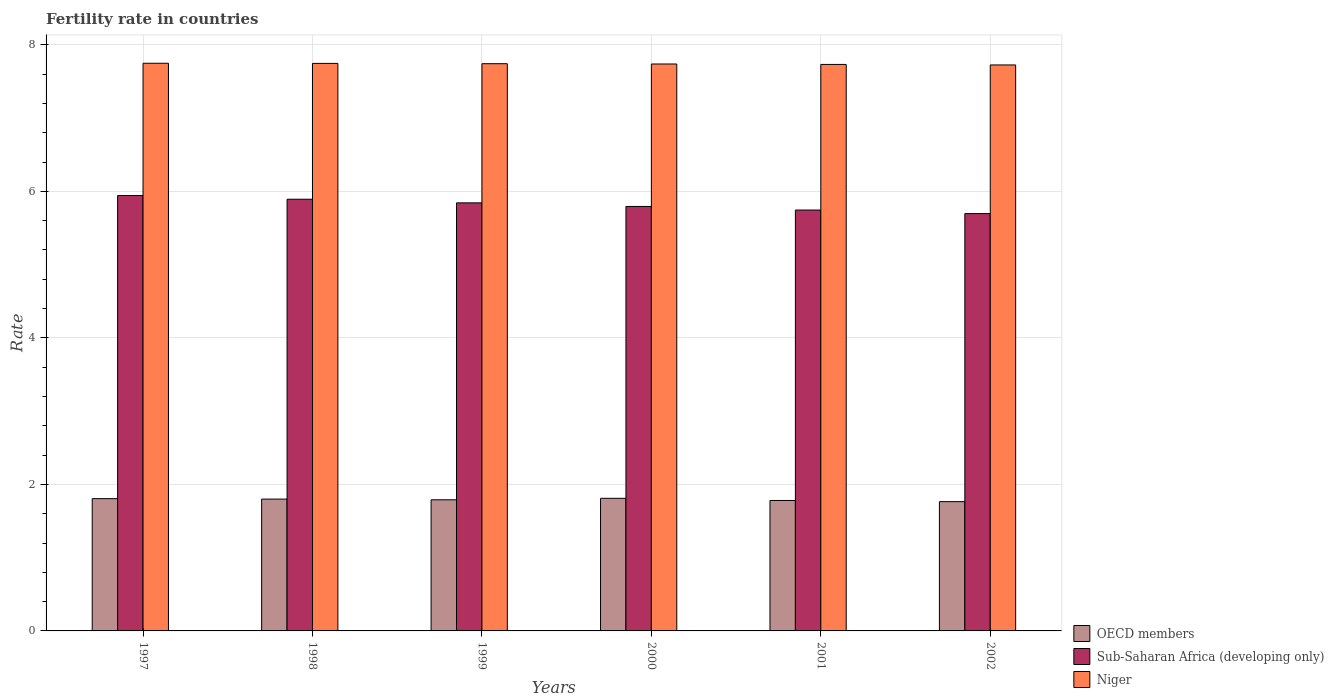How many different coloured bars are there?
Ensure brevity in your answer.  3. How many bars are there on the 3rd tick from the right?
Make the answer very short. 3. What is the label of the 6th group of bars from the left?
Your answer should be compact. 2002. What is the fertility rate in Sub-Saharan Africa (developing only) in 1997?
Make the answer very short. 5.94. Across all years, what is the maximum fertility rate in Sub-Saharan Africa (developing only)?
Offer a terse response. 5.94. Across all years, what is the minimum fertility rate in Sub-Saharan Africa (developing only)?
Offer a very short reply. 5.7. What is the total fertility rate in Niger in the graph?
Your answer should be very brief. 46.43. What is the difference between the fertility rate in Sub-Saharan Africa (developing only) in 1998 and that in 2002?
Give a very brief answer. 0.2. What is the difference between the fertility rate in OECD members in 2000 and the fertility rate in Sub-Saharan Africa (developing only) in 1998?
Your answer should be compact. -4.08. What is the average fertility rate in Niger per year?
Your answer should be very brief. 7.74. In the year 2002, what is the difference between the fertility rate in OECD members and fertility rate in Sub-Saharan Africa (developing only)?
Your answer should be compact. -3.93. What is the ratio of the fertility rate in Sub-Saharan Africa (developing only) in 1998 to that in 2002?
Your answer should be very brief. 1.03. What is the difference between the highest and the second highest fertility rate in Niger?
Provide a short and direct response. 0. What is the difference between the highest and the lowest fertility rate in OECD members?
Make the answer very short. 0.05. In how many years, is the fertility rate in Niger greater than the average fertility rate in Niger taken over all years?
Give a very brief answer. 3. Is the sum of the fertility rate in Niger in 1998 and 1999 greater than the maximum fertility rate in OECD members across all years?
Offer a very short reply. Yes. What does the 2nd bar from the left in 1998 represents?
Keep it short and to the point. Sub-Saharan Africa (developing only). What does the 3rd bar from the right in 2001 represents?
Provide a short and direct response. OECD members. Is it the case that in every year, the sum of the fertility rate in OECD members and fertility rate in Niger is greater than the fertility rate in Sub-Saharan Africa (developing only)?
Provide a succinct answer. Yes. Are all the bars in the graph horizontal?
Provide a short and direct response. No. Where does the legend appear in the graph?
Make the answer very short. Bottom right. How many legend labels are there?
Give a very brief answer. 3. What is the title of the graph?
Your answer should be compact. Fertility rate in countries. Does "South Sudan" appear as one of the legend labels in the graph?
Offer a very short reply. No. What is the label or title of the Y-axis?
Your answer should be compact. Rate. What is the Rate of OECD members in 1997?
Provide a short and direct response. 1.81. What is the Rate of Sub-Saharan Africa (developing only) in 1997?
Your answer should be very brief. 5.94. What is the Rate of Niger in 1997?
Ensure brevity in your answer.  7.75. What is the Rate of OECD members in 1998?
Your answer should be very brief. 1.8. What is the Rate of Sub-Saharan Africa (developing only) in 1998?
Provide a short and direct response. 5.89. What is the Rate in Niger in 1998?
Keep it short and to the point. 7.75. What is the Rate in OECD members in 1999?
Keep it short and to the point. 1.79. What is the Rate in Sub-Saharan Africa (developing only) in 1999?
Your response must be concise. 5.84. What is the Rate in Niger in 1999?
Your response must be concise. 7.74. What is the Rate in OECD members in 2000?
Your response must be concise. 1.81. What is the Rate in Sub-Saharan Africa (developing only) in 2000?
Ensure brevity in your answer.  5.79. What is the Rate in Niger in 2000?
Keep it short and to the point. 7.74. What is the Rate of OECD members in 2001?
Offer a terse response. 1.78. What is the Rate in Sub-Saharan Africa (developing only) in 2001?
Provide a succinct answer. 5.74. What is the Rate of Niger in 2001?
Ensure brevity in your answer.  7.73. What is the Rate in OECD members in 2002?
Make the answer very short. 1.76. What is the Rate of Sub-Saharan Africa (developing only) in 2002?
Your response must be concise. 5.7. What is the Rate of Niger in 2002?
Provide a succinct answer. 7.72. Across all years, what is the maximum Rate in OECD members?
Ensure brevity in your answer.  1.81. Across all years, what is the maximum Rate of Sub-Saharan Africa (developing only)?
Offer a terse response. 5.94. Across all years, what is the maximum Rate in Niger?
Give a very brief answer. 7.75. Across all years, what is the minimum Rate of OECD members?
Your response must be concise. 1.76. Across all years, what is the minimum Rate in Sub-Saharan Africa (developing only)?
Provide a succinct answer. 5.7. Across all years, what is the minimum Rate in Niger?
Provide a short and direct response. 7.72. What is the total Rate in OECD members in the graph?
Make the answer very short. 10.75. What is the total Rate of Sub-Saharan Africa (developing only) in the graph?
Make the answer very short. 34.91. What is the total Rate of Niger in the graph?
Make the answer very short. 46.43. What is the difference between the Rate of OECD members in 1997 and that in 1998?
Ensure brevity in your answer.  0.01. What is the difference between the Rate in Sub-Saharan Africa (developing only) in 1997 and that in 1998?
Offer a terse response. 0.05. What is the difference between the Rate in Niger in 1997 and that in 1998?
Your response must be concise. 0. What is the difference between the Rate in OECD members in 1997 and that in 1999?
Your response must be concise. 0.02. What is the difference between the Rate of Sub-Saharan Africa (developing only) in 1997 and that in 1999?
Ensure brevity in your answer.  0.1. What is the difference between the Rate of Niger in 1997 and that in 1999?
Provide a short and direct response. 0.01. What is the difference between the Rate of OECD members in 1997 and that in 2000?
Your answer should be very brief. -0. What is the difference between the Rate of Sub-Saharan Africa (developing only) in 1997 and that in 2000?
Give a very brief answer. 0.15. What is the difference between the Rate in Niger in 1997 and that in 2000?
Offer a very short reply. 0.01. What is the difference between the Rate in OECD members in 1997 and that in 2001?
Your response must be concise. 0.02. What is the difference between the Rate of Sub-Saharan Africa (developing only) in 1997 and that in 2001?
Ensure brevity in your answer.  0.2. What is the difference between the Rate of Niger in 1997 and that in 2001?
Offer a very short reply. 0.02. What is the difference between the Rate of OECD members in 1997 and that in 2002?
Your answer should be very brief. 0.04. What is the difference between the Rate in Sub-Saharan Africa (developing only) in 1997 and that in 2002?
Your answer should be compact. 0.25. What is the difference between the Rate in Niger in 1997 and that in 2002?
Keep it short and to the point. 0.02. What is the difference between the Rate in OECD members in 1998 and that in 1999?
Offer a very short reply. 0.01. What is the difference between the Rate in Sub-Saharan Africa (developing only) in 1998 and that in 1999?
Offer a terse response. 0.05. What is the difference between the Rate of Niger in 1998 and that in 1999?
Make the answer very short. 0. What is the difference between the Rate in OECD members in 1998 and that in 2000?
Give a very brief answer. -0.01. What is the difference between the Rate of Sub-Saharan Africa (developing only) in 1998 and that in 2000?
Provide a succinct answer. 0.1. What is the difference between the Rate of Niger in 1998 and that in 2000?
Your response must be concise. 0.01. What is the difference between the Rate in OECD members in 1998 and that in 2001?
Your answer should be very brief. 0.02. What is the difference between the Rate in Sub-Saharan Africa (developing only) in 1998 and that in 2001?
Your answer should be very brief. 0.15. What is the difference between the Rate in Niger in 1998 and that in 2001?
Your answer should be compact. 0.01. What is the difference between the Rate of OECD members in 1998 and that in 2002?
Ensure brevity in your answer.  0.03. What is the difference between the Rate of Sub-Saharan Africa (developing only) in 1998 and that in 2002?
Provide a short and direct response. 0.2. What is the difference between the Rate in Niger in 1998 and that in 2002?
Your response must be concise. 0.02. What is the difference between the Rate in OECD members in 1999 and that in 2000?
Make the answer very short. -0.02. What is the difference between the Rate in Sub-Saharan Africa (developing only) in 1999 and that in 2000?
Your response must be concise. 0.05. What is the difference between the Rate in Niger in 1999 and that in 2000?
Give a very brief answer. 0. What is the difference between the Rate of OECD members in 1999 and that in 2001?
Keep it short and to the point. 0.01. What is the difference between the Rate in Sub-Saharan Africa (developing only) in 1999 and that in 2001?
Keep it short and to the point. 0.1. What is the difference between the Rate of Niger in 1999 and that in 2001?
Keep it short and to the point. 0.01. What is the difference between the Rate of OECD members in 1999 and that in 2002?
Keep it short and to the point. 0.03. What is the difference between the Rate of Sub-Saharan Africa (developing only) in 1999 and that in 2002?
Your answer should be compact. 0.15. What is the difference between the Rate in Niger in 1999 and that in 2002?
Offer a very short reply. 0.02. What is the difference between the Rate in OECD members in 2000 and that in 2001?
Make the answer very short. 0.03. What is the difference between the Rate of Sub-Saharan Africa (developing only) in 2000 and that in 2001?
Your answer should be very brief. 0.05. What is the difference between the Rate in Niger in 2000 and that in 2001?
Keep it short and to the point. 0.01. What is the difference between the Rate of OECD members in 2000 and that in 2002?
Your answer should be compact. 0.05. What is the difference between the Rate of Sub-Saharan Africa (developing only) in 2000 and that in 2002?
Your answer should be compact. 0.1. What is the difference between the Rate of Niger in 2000 and that in 2002?
Keep it short and to the point. 0.01. What is the difference between the Rate in OECD members in 2001 and that in 2002?
Ensure brevity in your answer.  0.02. What is the difference between the Rate of Sub-Saharan Africa (developing only) in 2001 and that in 2002?
Give a very brief answer. 0.05. What is the difference between the Rate in Niger in 2001 and that in 2002?
Ensure brevity in your answer.  0.01. What is the difference between the Rate in OECD members in 1997 and the Rate in Sub-Saharan Africa (developing only) in 1998?
Offer a terse response. -4.09. What is the difference between the Rate of OECD members in 1997 and the Rate of Niger in 1998?
Your response must be concise. -5.94. What is the difference between the Rate of Sub-Saharan Africa (developing only) in 1997 and the Rate of Niger in 1998?
Provide a short and direct response. -1.8. What is the difference between the Rate in OECD members in 1997 and the Rate in Sub-Saharan Africa (developing only) in 1999?
Your answer should be compact. -4.04. What is the difference between the Rate of OECD members in 1997 and the Rate of Niger in 1999?
Your answer should be very brief. -5.94. What is the difference between the Rate of Sub-Saharan Africa (developing only) in 1997 and the Rate of Niger in 1999?
Your answer should be very brief. -1.8. What is the difference between the Rate in OECD members in 1997 and the Rate in Sub-Saharan Africa (developing only) in 2000?
Offer a very short reply. -3.99. What is the difference between the Rate in OECD members in 1997 and the Rate in Niger in 2000?
Provide a short and direct response. -5.93. What is the difference between the Rate in Sub-Saharan Africa (developing only) in 1997 and the Rate in Niger in 2000?
Provide a succinct answer. -1.8. What is the difference between the Rate of OECD members in 1997 and the Rate of Sub-Saharan Africa (developing only) in 2001?
Give a very brief answer. -3.94. What is the difference between the Rate of OECD members in 1997 and the Rate of Niger in 2001?
Make the answer very short. -5.93. What is the difference between the Rate in Sub-Saharan Africa (developing only) in 1997 and the Rate in Niger in 2001?
Make the answer very short. -1.79. What is the difference between the Rate in OECD members in 1997 and the Rate in Sub-Saharan Africa (developing only) in 2002?
Your answer should be very brief. -3.89. What is the difference between the Rate of OECD members in 1997 and the Rate of Niger in 2002?
Offer a very short reply. -5.92. What is the difference between the Rate of Sub-Saharan Africa (developing only) in 1997 and the Rate of Niger in 2002?
Provide a succinct answer. -1.78. What is the difference between the Rate in OECD members in 1998 and the Rate in Sub-Saharan Africa (developing only) in 1999?
Make the answer very short. -4.04. What is the difference between the Rate of OECD members in 1998 and the Rate of Niger in 1999?
Your response must be concise. -5.94. What is the difference between the Rate in Sub-Saharan Africa (developing only) in 1998 and the Rate in Niger in 1999?
Your answer should be very brief. -1.85. What is the difference between the Rate of OECD members in 1998 and the Rate of Sub-Saharan Africa (developing only) in 2000?
Offer a terse response. -3.99. What is the difference between the Rate in OECD members in 1998 and the Rate in Niger in 2000?
Your response must be concise. -5.94. What is the difference between the Rate of Sub-Saharan Africa (developing only) in 1998 and the Rate of Niger in 2000?
Give a very brief answer. -1.85. What is the difference between the Rate in OECD members in 1998 and the Rate in Sub-Saharan Africa (developing only) in 2001?
Your answer should be very brief. -3.95. What is the difference between the Rate of OECD members in 1998 and the Rate of Niger in 2001?
Offer a very short reply. -5.93. What is the difference between the Rate of Sub-Saharan Africa (developing only) in 1998 and the Rate of Niger in 2001?
Your answer should be very brief. -1.84. What is the difference between the Rate in OECD members in 1998 and the Rate in Sub-Saharan Africa (developing only) in 2002?
Keep it short and to the point. -3.9. What is the difference between the Rate in OECD members in 1998 and the Rate in Niger in 2002?
Offer a very short reply. -5.93. What is the difference between the Rate of Sub-Saharan Africa (developing only) in 1998 and the Rate of Niger in 2002?
Your answer should be compact. -1.83. What is the difference between the Rate in OECD members in 1999 and the Rate in Sub-Saharan Africa (developing only) in 2000?
Offer a very short reply. -4. What is the difference between the Rate in OECD members in 1999 and the Rate in Niger in 2000?
Give a very brief answer. -5.95. What is the difference between the Rate of Sub-Saharan Africa (developing only) in 1999 and the Rate of Niger in 2000?
Provide a succinct answer. -1.9. What is the difference between the Rate of OECD members in 1999 and the Rate of Sub-Saharan Africa (developing only) in 2001?
Give a very brief answer. -3.95. What is the difference between the Rate in OECD members in 1999 and the Rate in Niger in 2001?
Offer a terse response. -5.94. What is the difference between the Rate of Sub-Saharan Africa (developing only) in 1999 and the Rate of Niger in 2001?
Provide a succinct answer. -1.89. What is the difference between the Rate in OECD members in 1999 and the Rate in Sub-Saharan Africa (developing only) in 2002?
Offer a terse response. -3.91. What is the difference between the Rate of OECD members in 1999 and the Rate of Niger in 2002?
Your answer should be compact. -5.94. What is the difference between the Rate of Sub-Saharan Africa (developing only) in 1999 and the Rate of Niger in 2002?
Offer a terse response. -1.88. What is the difference between the Rate in OECD members in 2000 and the Rate in Sub-Saharan Africa (developing only) in 2001?
Provide a short and direct response. -3.93. What is the difference between the Rate of OECD members in 2000 and the Rate of Niger in 2001?
Make the answer very short. -5.92. What is the difference between the Rate of Sub-Saharan Africa (developing only) in 2000 and the Rate of Niger in 2001?
Keep it short and to the point. -1.94. What is the difference between the Rate in OECD members in 2000 and the Rate in Sub-Saharan Africa (developing only) in 2002?
Give a very brief answer. -3.89. What is the difference between the Rate of OECD members in 2000 and the Rate of Niger in 2002?
Offer a terse response. -5.92. What is the difference between the Rate of Sub-Saharan Africa (developing only) in 2000 and the Rate of Niger in 2002?
Make the answer very short. -1.93. What is the difference between the Rate of OECD members in 2001 and the Rate of Sub-Saharan Africa (developing only) in 2002?
Offer a very short reply. -3.92. What is the difference between the Rate in OECD members in 2001 and the Rate in Niger in 2002?
Offer a terse response. -5.94. What is the difference between the Rate of Sub-Saharan Africa (developing only) in 2001 and the Rate of Niger in 2002?
Give a very brief answer. -1.98. What is the average Rate in OECD members per year?
Provide a succinct answer. 1.79. What is the average Rate in Sub-Saharan Africa (developing only) per year?
Your answer should be compact. 5.82. What is the average Rate in Niger per year?
Offer a terse response. 7.74. In the year 1997, what is the difference between the Rate in OECD members and Rate in Sub-Saharan Africa (developing only)?
Your answer should be compact. -4.14. In the year 1997, what is the difference between the Rate in OECD members and Rate in Niger?
Ensure brevity in your answer.  -5.94. In the year 1997, what is the difference between the Rate in Sub-Saharan Africa (developing only) and Rate in Niger?
Offer a very short reply. -1.81. In the year 1998, what is the difference between the Rate in OECD members and Rate in Sub-Saharan Africa (developing only)?
Offer a very short reply. -4.09. In the year 1998, what is the difference between the Rate of OECD members and Rate of Niger?
Provide a short and direct response. -5.95. In the year 1998, what is the difference between the Rate of Sub-Saharan Africa (developing only) and Rate of Niger?
Provide a succinct answer. -1.85. In the year 1999, what is the difference between the Rate of OECD members and Rate of Sub-Saharan Africa (developing only)?
Ensure brevity in your answer.  -4.05. In the year 1999, what is the difference between the Rate of OECD members and Rate of Niger?
Ensure brevity in your answer.  -5.95. In the year 1999, what is the difference between the Rate in Sub-Saharan Africa (developing only) and Rate in Niger?
Your response must be concise. -1.9. In the year 2000, what is the difference between the Rate in OECD members and Rate in Sub-Saharan Africa (developing only)?
Your answer should be compact. -3.98. In the year 2000, what is the difference between the Rate of OECD members and Rate of Niger?
Offer a very short reply. -5.93. In the year 2000, what is the difference between the Rate in Sub-Saharan Africa (developing only) and Rate in Niger?
Your answer should be compact. -1.94. In the year 2001, what is the difference between the Rate of OECD members and Rate of Sub-Saharan Africa (developing only)?
Keep it short and to the point. -3.96. In the year 2001, what is the difference between the Rate of OECD members and Rate of Niger?
Your answer should be compact. -5.95. In the year 2001, what is the difference between the Rate of Sub-Saharan Africa (developing only) and Rate of Niger?
Provide a succinct answer. -1.99. In the year 2002, what is the difference between the Rate of OECD members and Rate of Sub-Saharan Africa (developing only)?
Your answer should be compact. -3.93. In the year 2002, what is the difference between the Rate of OECD members and Rate of Niger?
Offer a very short reply. -5.96. In the year 2002, what is the difference between the Rate of Sub-Saharan Africa (developing only) and Rate of Niger?
Your answer should be very brief. -2.03. What is the ratio of the Rate in Sub-Saharan Africa (developing only) in 1997 to that in 1998?
Your answer should be very brief. 1.01. What is the ratio of the Rate of Niger in 1997 to that in 1998?
Provide a short and direct response. 1. What is the ratio of the Rate in OECD members in 1997 to that in 1999?
Keep it short and to the point. 1.01. What is the ratio of the Rate in Sub-Saharan Africa (developing only) in 1997 to that in 1999?
Provide a succinct answer. 1.02. What is the ratio of the Rate in Sub-Saharan Africa (developing only) in 1997 to that in 2000?
Your answer should be compact. 1.03. What is the ratio of the Rate in Niger in 1997 to that in 2000?
Your response must be concise. 1. What is the ratio of the Rate in OECD members in 1997 to that in 2001?
Give a very brief answer. 1.01. What is the ratio of the Rate in Sub-Saharan Africa (developing only) in 1997 to that in 2001?
Give a very brief answer. 1.03. What is the ratio of the Rate of OECD members in 1997 to that in 2002?
Provide a succinct answer. 1.02. What is the ratio of the Rate in Sub-Saharan Africa (developing only) in 1997 to that in 2002?
Give a very brief answer. 1.04. What is the ratio of the Rate in OECD members in 1998 to that in 1999?
Give a very brief answer. 1.01. What is the ratio of the Rate of Sub-Saharan Africa (developing only) in 1998 to that in 1999?
Give a very brief answer. 1.01. What is the ratio of the Rate of OECD members in 1998 to that in 2000?
Make the answer very short. 0.99. What is the ratio of the Rate of Niger in 1998 to that in 2000?
Your answer should be very brief. 1. What is the ratio of the Rate of OECD members in 1998 to that in 2001?
Make the answer very short. 1.01. What is the ratio of the Rate in Sub-Saharan Africa (developing only) in 1998 to that in 2001?
Give a very brief answer. 1.03. What is the ratio of the Rate of OECD members in 1998 to that in 2002?
Offer a very short reply. 1.02. What is the ratio of the Rate of Sub-Saharan Africa (developing only) in 1998 to that in 2002?
Your answer should be compact. 1.03. What is the ratio of the Rate of Sub-Saharan Africa (developing only) in 1999 to that in 2000?
Your answer should be very brief. 1.01. What is the ratio of the Rate in OECD members in 1999 to that in 2001?
Your answer should be very brief. 1.01. What is the ratio of the Rate in Sub-Saharan Africa (developing only) in 1999 to that in 2001?
Ensure brevity in your answer.  1.02. What is the ratio of the Rate in OECD members in 1999 to that in 2002?
Offer a terse response. 1.01. What is the ratio of the Rate in Sub-Saharan Africa (developing only) in 1999 to that in 2002?
Your answer should be very brief. 1.03. What is the ratio of the Rate in OECD members in 2000 to that in 2001?
Ensure brevity in your answer.  1.02. What is the ratio of the Rate in Sub-Saharan Africa (developing only) in 2000 to that in 2001?
Make the answer very short. 1.01. What is the ratio of the Rate in OECD members in 2000 to that in 2002?
Your response must be concise. 1.03. What is the ratio of the Rate in Sub-Saharan Africa (developing only) in 2000 to that in 2002?
Ensure brevity in your answer.  1.02. What is the ratio of the Rate of Sub-Saharan Africa (developing only) in 2001 to that in 2002?
Give a very brief answer. 1.01. What is the difference between the highest and the second highest Rate of OECD members?
Provide a succinct answer. 0. What is the difference between the highest and the second highest Rate of Sub-Saharan Africa (developing only)?
Your response must be concise. 0.05. What is the difference between the highest and the second highest Rate of Niger?
Offer a very short reply. 0. What is the difference between the highest and the lowest Rate in OECD members?
Your response must be concise. 0.05. What is the difference between the highest and the lowest Rate of Sub-Saharan Africa (developing only)?
Keep it short and to the point. 0.25. What is the difference between the highest and the lowest Rate in Niger?
Provide a short and direct response. 0.02. 